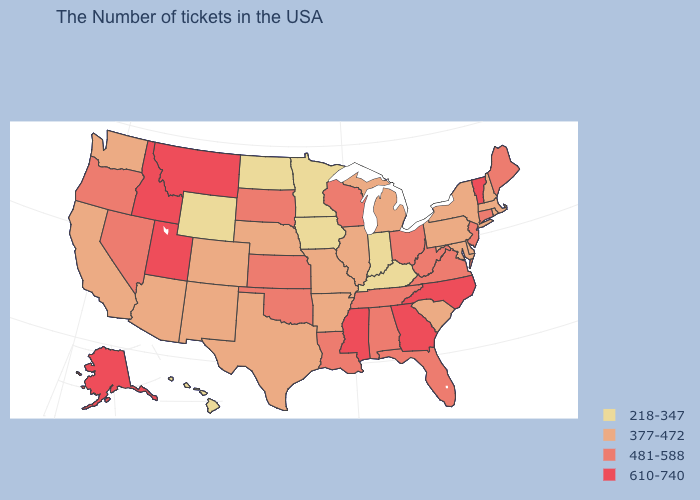Among the states that border Utah , does Arizona have the highest value?
Quick response, please. No. What is the value of Connecticut?
Be succinct. 481-588. Does the map have missing data?
Give a very brief answer. No. What is the value of Virginia?
Answer briefly. 481-588. What is the value of New Mexico?
Concise answer only. 377-472. What is the value of New Jersey?
Give a very brief answer. 481-588. Does Florida have the highest value in the USA?
Concise answer only. No. Does the first symbol in the legend represent the smallest category?
Write a very short answer. Yes. Name the states that have a value in the range 377-472?
Short answer required. Massachusetts, Rhode Island, New Hampshire, New York, Delaware, Maryland, Pennsylvania, South Carolina, Michigan, Illinois, Missouri, Arkansas, Nebraska, Texas, Colorado, New Mexico, Arizona, California, Washington. What is the highest value in the USA?
Be succinct. 610-740. Name the states that have a value in the range 481-588?
Short answer required. Maine, Connecticut, New Jersey, Virginia, West Virginia, Ohio, Florida, Alabama, Tennessee, Wisconsin, Louisiana, Kansas, Oklahoma, South Dakota, Nevada, Oregon. Name the states that have a value in the range 218-347?
Write a very short answer. Kentucky, Indiana, Minnesota, Iowa, North Dakota, Wyoming, Hawaii. Name the states that have a value in the range 377-472?
Concise answer only. Massachusetts, Rhode Island, New Hampshire, New York, Delaware, Maryland, Pennsylvania, South Carolina, Michigan, Illinois, Missouri, Arkansas, Nebraska, Texas, Colorado, New Mexico, Arizona, California, Washington. What is the highest value in states that border Massachusetts?
Quick response, please. 610-740. Name the states that have a value in the range 481-588?
Be succinct. Maine, Connecticut, New Jersey, Virginia, West Virginia, Ohio, Florida, Alabama, Tennessee, Wisconsin, Louisiana, Kansas, Oklahoma, South Dakota, Nevada, Oregon. 